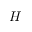Convert formula to latex. <formula><loc_0><loc_0><loc_500><loc_500>H</formula> 